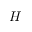Convert formula to latex. <formula><loc_0><loc_0><loc_500><loc_500>H</formula> 